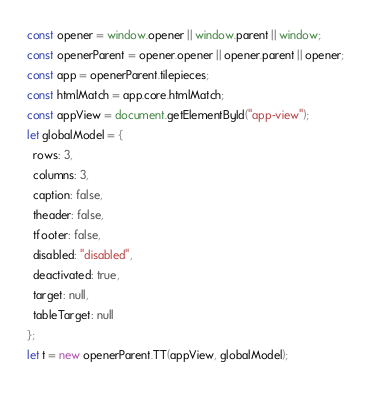Convert code to text. <code><loc_0><loc_0><loc_500><loc_500><_JavaScript_>const opener = window.opener || window.parent || window;
const openerParent = opener.opener || opener.parent || opener;
const app = openerParent.tilepieces;
const htmlMatch = app.core.htmlMatch;
const appView = document.getElementById("app-view");
let globalModel = {
  rows: 3,
  columns: 3,
  caption: false,
  theader: false,
  tfooter: false,
  disabled: "disabled",
  deactivated: true,
  target: null,
  tableTarget: null
};
let t = new openerParent.TT(appView, globalModel);</code> 